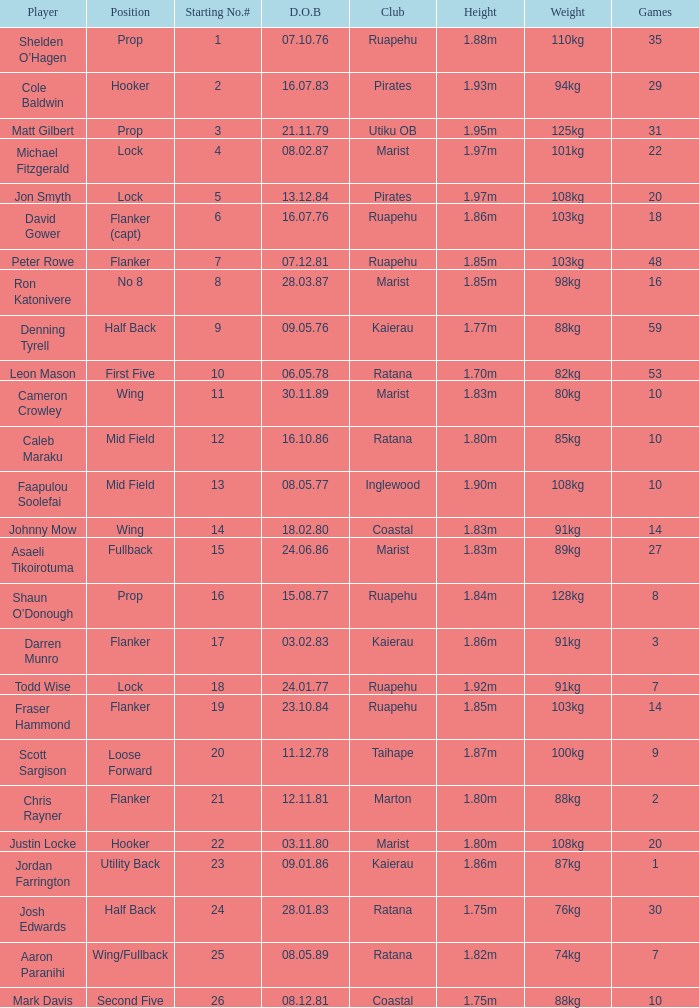Which player weighs 76kg? Josh Edwards. 